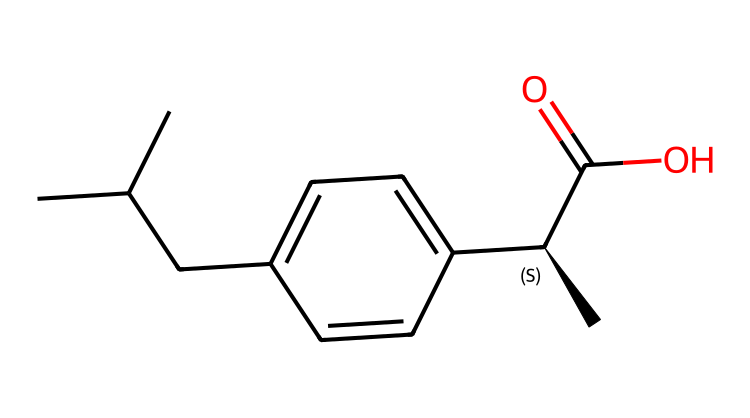What is the name of this chemical? The SMILES provided corresponds to ibuprofen, which is recognizable due to its characteristic structure featuring a propionic acid functional group (C(=O)O) and a phenyl ring.
Answer: ibuprofen How many chiral centers are present in ibuprofen? The SMILES representation indicates there is one chiral center, denoted by the stereocenter designation [C@H], which signifies the presence of a specific spatial arrangement of atoms.
Answer: one What is the molecular formula of ibuprofen? By analyzing the components in the SMILES encoding, the molecular formula can be determined as C13H18O2. This includes all the carbon, hydrogen, and oxygen atoms present in the structure.
Answer: C13H18O2 Does ibuprofen exist as enantiomers? Yes, ibuprofen is a chiral compound and has two enantiomers due to the presence of its single chiral center, which results in non-superimposable mirror images.
Answer: yes How many carbon atoms are in ibuprofen? Counting the carbon atoms in the provided SMILES reveals there are 13 carbon atoms in total, both in the chain and aromatic ring.
Answer: 13 What kind of compound is ibuprofen classified as? Ibuprofen is classified as a non-steroidal anti-inflammatory drug (NSAID), indicated by its structure, which contains a phenyl ring and a carboxylic acid.
Answer: NSAID What functional groups are present in ibuprofen? The functional groups present in ibuprofen include a carboxylic acid group (C(=O)O) and an alkyl side chain, which identify its reactivity and properties.
Answer: carboxylic acid and alkyl 